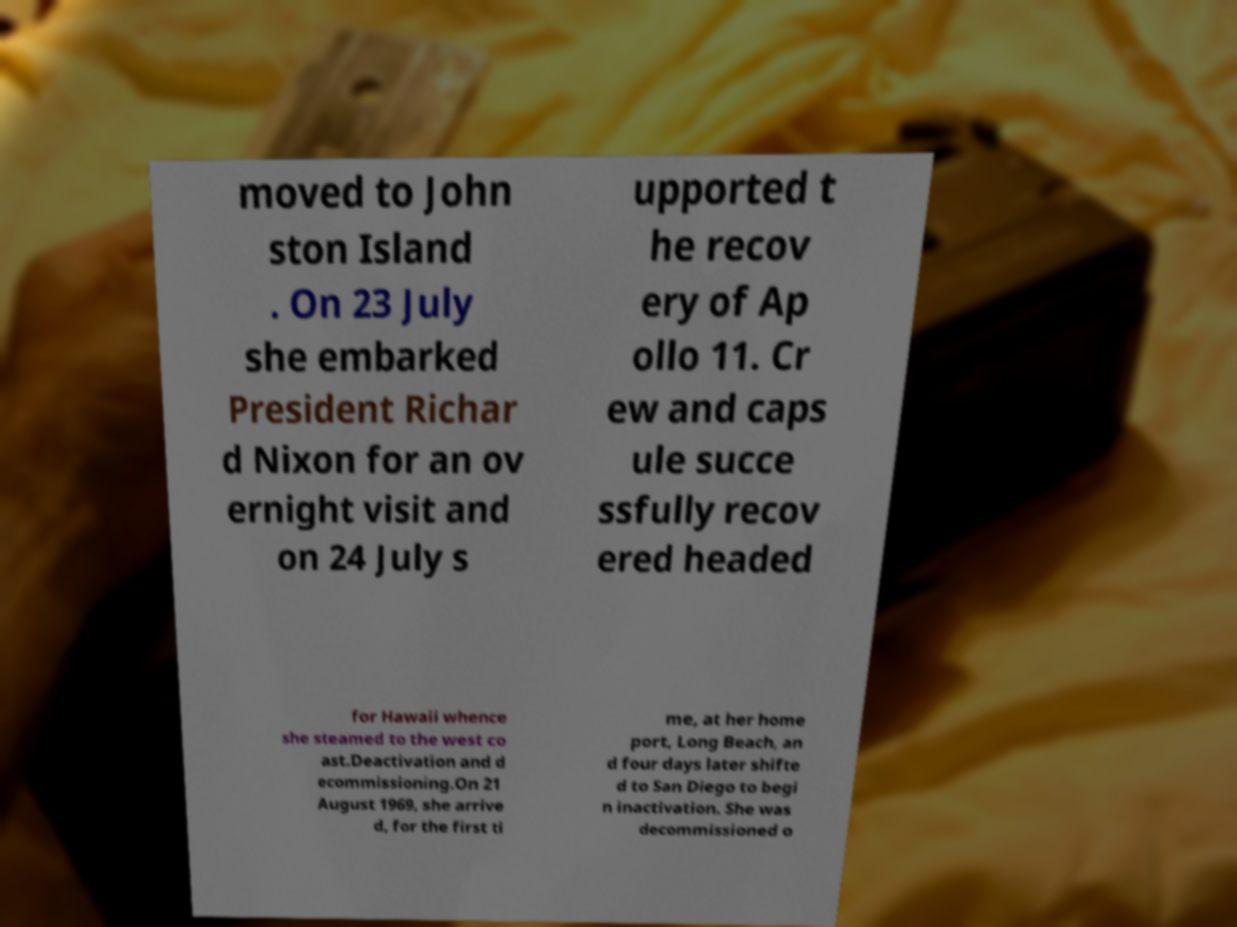Please identify and transcribe the text found in this image. moved to John ston Island . On 23 July she embarked President Richar d Nixon for an ov ernight visit and on 24 July s upported t he recov ery of Ap ollo 11. Cr ew and caps ule succe ssfully recov ered headed for Hawaii whence she steamed to the west co ast.Deactivation and d ecommissioning.On 21 August 1969, she arrive d, for the first ti me, at her home port, Long Beach, an d four days later shifte d to San Diego to begi n inactivation. She was decommissioned o 